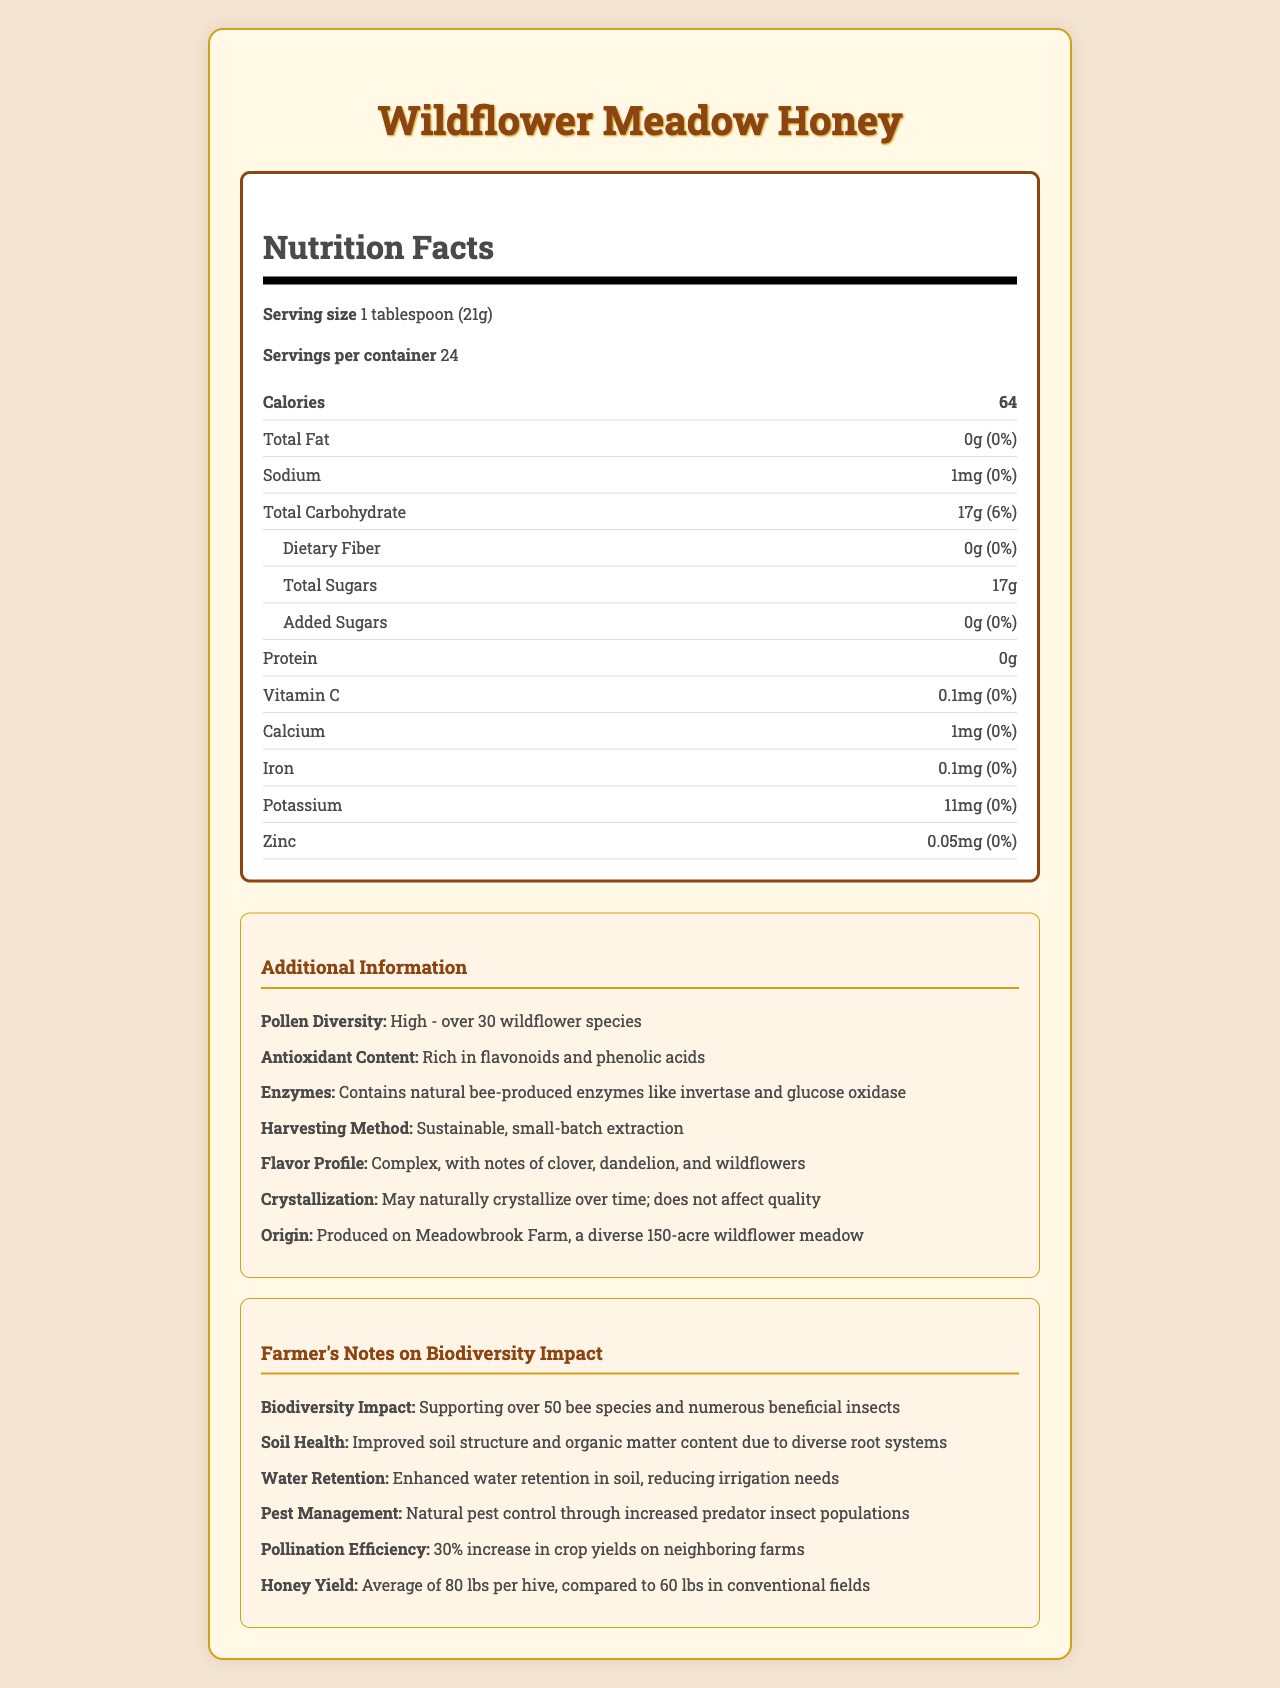how many calories are in a serving of Wildflower Meadow Honey? The document shows that each serving (1 tablespoon or 21g) contains 64 calories.
Answer: 64 how much sodium is in each serving? The nutrition label clearly states that a serving of honey contains 1mg of sodium.
Answer: 1mg what is the flavor profile of Wildflower Meadow Honey? This information is listed under the "Additional Information" section of the document.
Answer: Complex, with notes of clover, dandelion, and wildflowers how many grams of total sugars are in a serving? The nutrition label shows that each serving contains 17 grams of total sugars.
Answer: 17g what types of enzymes are in the honey? These enzymes are mentioned in the "Additional Information" section.
Answer: Invertase and glucose oxidase what is the origin of the Wildflower Meadow Honey? A. Amazon Rainforest B. Meadowbrook Farm C. Himalayan Mountains D. Meadow Ridge Farm The "Additional Information" section indicates Meadowbrook Farm as the origin.
Answer: B how much potassium is in one serving? A. 5mg B. 11mg C. 15mg D. 20mg The nutrition facts state that each serving contains 11mg of potassium.
Answer: B does Wildflower Meadow Honey contain any added sugars? The document specifies that the honey contains 0g of added sugars.
Answer: No summarize the main idea of the document. The document comprehensively covers the nutritional facts, additional properties, and the impact of sustainable farming practices on the honey's quality and the environment.
Answer: The document provides detailed nutritional information and additional insights about Wildflower Meadow Honey. It includes the nutritional breakdown per serving, additional characteristics like pollen diversity, antioxidant content, enzymes, and the origins of the honey. It also highlights the benefits of biodiversity practices implemented by the farmer. what is the total carbohydrate content and percentage of daily value per serving? The document shows that one serving contains 17 grams of total carbohydrates, which is 6% of the daily value.
Answer: 17g, 6% what impact does the biodiversity practice have on pest management? The "Farmer's Notes" section mentions that biodiversity practices lead to natural pest control by increasing predator insect populations.
Answer: Natural pest control through increased predator insect populations how many bee species does the Wildflower Meadow Honey support? The "Farmer's Notes" section indicates that the honey supports over 50 bee species.
Answer: Over 50 can the crystallization of the honey affect its quality? The "Additional Information" section states that crystallization may occur naturally over time but does not affect the quality.
Answer: No what color border surrounds the nutrition label? The document uses visual information to describe the color of the border around the nutrition label, which is brown.
Answer: The border is brown. how much iron is in each serving? The nutrition label mentions that each serving contains 0.1mg of iron.
Answer: 0.1mg how does biodiversity impact soil health according to the farmer notes? The "Farmer's Notes" section explains that the diverse root systems from biodiversity practices improve soil structure and organic matter content.
Answer: Improved soil structure and organic matter content due to diverse root systems does the honey contain any dietary fiber? The document shows that there is 0g of dietary fiber in each serving of honey.
Answer: No how many calories come from fat in a serving of Wildflower Meadow Honey? The document lists the total fat as 0g, but it does not explicitly provide the number of calories from fat.
Answer: Cannot be determined what improvement in crop yields was observed on neighboring farms due to pollination? The "Farmer's Notes" section indicates that there was a 30% increase in crop yields on neighboring farms.
Answer: 30% increase how much calcium is in a serving of Wildflower Meadow Honey? The nutrition label shows that each serving contains 1mg of calcium.
Answer: 1mg 